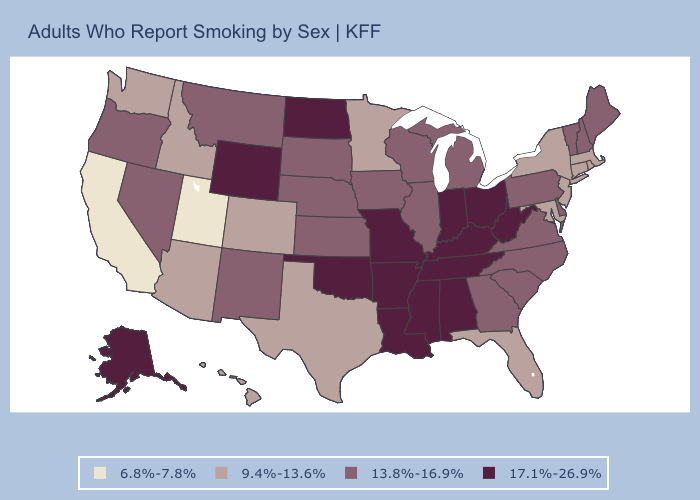What is the value of Florida?
Keep it brief. 9.4%-13.6%. Which states have the highest value in the USA?
Give a very brief answer. Alabama, Alaska, Arkansas, Indiana, Kentucky, Louisiana, Mississippi, Missouri, North Dakota, Ohio, Oklahoma, Tennessee, West Virginia, Wyoming. Which states have the lowest value in the South?
Short answer required. Florida, Maryland, Texas. Name the states that have a value in the range 6.8%-7.8%?
Answer briefly. California, Utah. What is the value of Rhode Island?
Give a very brief answer. 9.4%-13.6%. What is the value of Illinois?
Concise answer only. 13.8%-16.9%. Name the states that have a value in the range 17.1%-26.9%?
Be succinct. Alabama, Alaska, Arkansas, Indiana, Kentucky, Louisiana, Mississippi, Missouri, North Dakota, Ohio, Oklahoma, Tennessee, West Virginia, Wyoming. Name the states that have a value in the range 9.4%-13.6%?
Give a very brief answer. Arizona, Colorado, Connecticut, Florida, Hawaii, Idaho, Maryland, Massachusetts, Minnesota, New Jersey, New York, Rhode Island, Texas, Washington. What is the value of Maine?
Be succinct. 13.8%-16.9%. Does Idaho have the lowest value in the West?
Write a very short answer. No. Name the states that have a value in the range 6.8%-7.8%?
Keep it brief. California, Utah. Does New Jersey have the highest value in the Northeast?
Write a very short answer. No. Does Idaho have the lowest value in the USA?
Concise answer only. No. What is the lowest value in states that border South Carolina?
Short answer required. 13.8%-16.9%. Is the legend a continuous bar?
Give a very brief answer. No. 